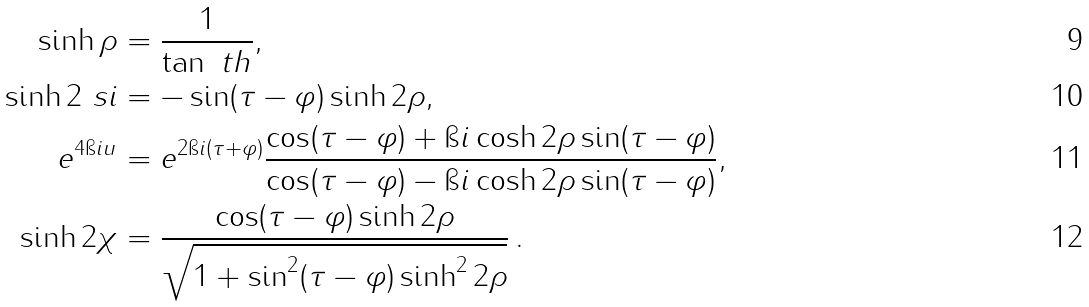Convert formula to latex. <formula><loc_0><loc_0><loc_500><loc_500>\sinh \rho & = \frac { 1 } { \tan \ t h } , \\ \sinh 2 \ s i & = - \sin ( \tau - \varphi ) \sinh 2 \rho , \\ e ^ { 4 \i i u } & = e ^ { 2 \i i ( \tau + \varphi ) } \frac { \cos ( \tau - \varphi ) + \i i \cosh 2 \rho \sin ( \tau - \varphi ) } { \cos ( \tau - \varphi ) - \i i \cosh 2 \rho \sin ( \tau - \varphi ) } , \\ \sinh 2 \chi & = \frac { \cos ( \tau - \varphi ) \sinh 2 \rho } { \sqrt { 1 + \sin ^ { 2 } ( \tau - \varphi ) \sinh ^ { 2 } 2 \rho } } \, .</formula> 